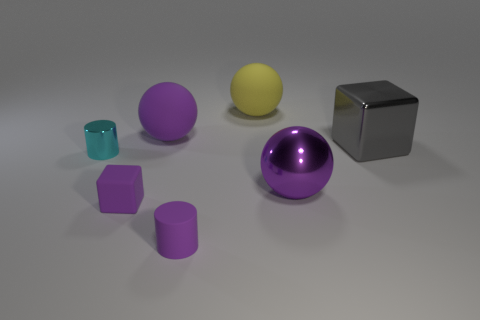Is the size of the gray object the same as the yellow sphere? Upon closer inspection, the size of the gray cube and the yellow sphere are not exactly the same. The yellow sphere appears to be slightly smaller than the gray cube when comparing their dimensions. 